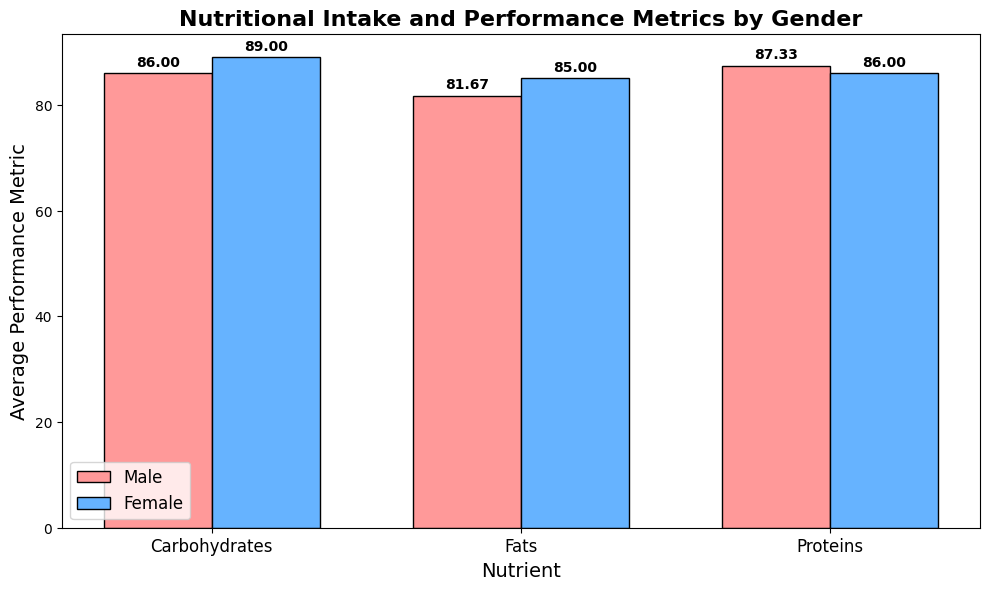What is the average performance metric for males consuming carbohydrates? Look at the bar representing males in the carbohydrate category. The height of the bar is marked as 86.
Answer: 86 Which gender has a higher average performance metric for proteins? Compare the heights of the bars for males and females in the protein category. The male bar is higher than the female bar, indicating a performance metric of 87 for males compared to 86 for females.
Answer: Males For fats, what is the difference in average performance metrics between males and females? Identify the heights of the bars for males and females in the fats category. The male bar is at 81.67, and the female bar is at 85. The difference is calculated as 85 - 81.67.
Answer: 3.33 Which nutrient has the highest average performance metric for females? Inspect the heights of all the bars under the female category. The tallest bar is for carbohydrates with a height of 89.
Answer: Carbohydrates Is there any nutrient where females significantly outperformed males? Compare all pairs of bars for each nutrient between genders. The nutrient with the largest difference where females are superior is Fat, with women scoring 85 compared to men’s 81.67 (difference of 3.33).
Answer: Fats What is the combined average performance metric for males across all nutrients? Sum the average performance metrics for males across carbohydrates (86), proteins (87), and fats (81.67), then divide by 3. (86 + 87 + 81.67)/3
Answer: 84.89 How does the average performance metric for males consuming proteins compare to females consuming fats? Evaluate the average performance metrics: males consuming proteins have a metric of 87, and females consuming fats have a metric of 85.
Answer: Males For which nutrient does the smallest gender performance gap exist? Calculate the performance difference for each nutrient: Carbohydrates (3), Proteins (1), Fats (3.33). The smallest gap is in Proteins.
Answer: Proteins Which nutrient shows the lowest average performance metric for males? Examine the values of the male performance metrics for all nutrients. The smallest value is for fats at 81.67.
Answer: Fats 